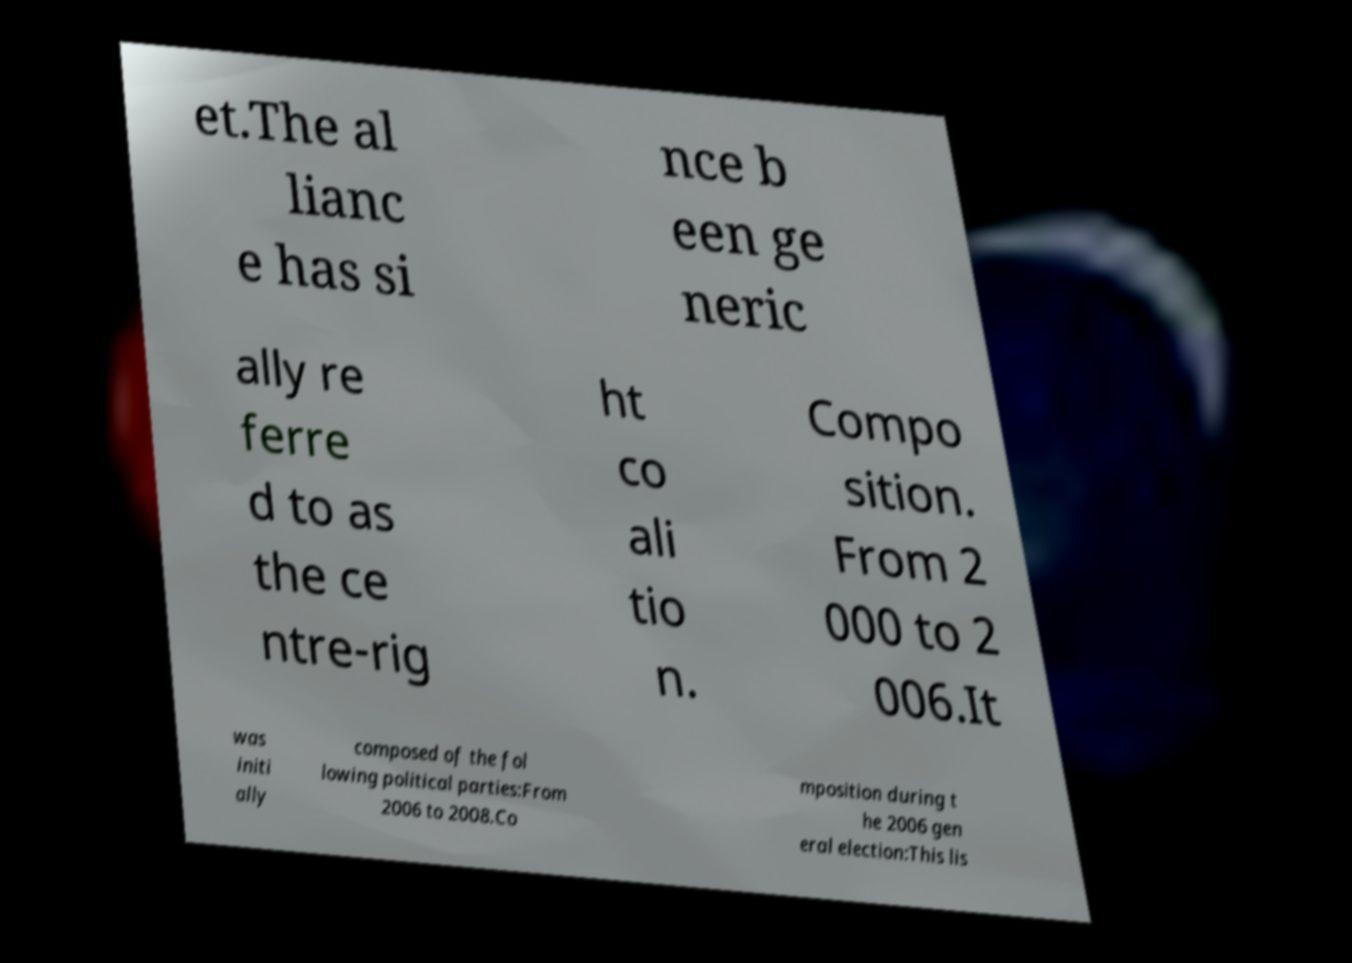I need the written content from this picture converted into text. Can you do that? et.The al lianc e has si nce b een ge neric ally re ferre d to as the ce ntre-rig ht co ali tio n. Compo sition. From 2 000 to 2 006.It was initi ally composed of the fol lowing political parties:From 2006 to 2008.Co mposition during t he 2006 gen eral election:This lis 